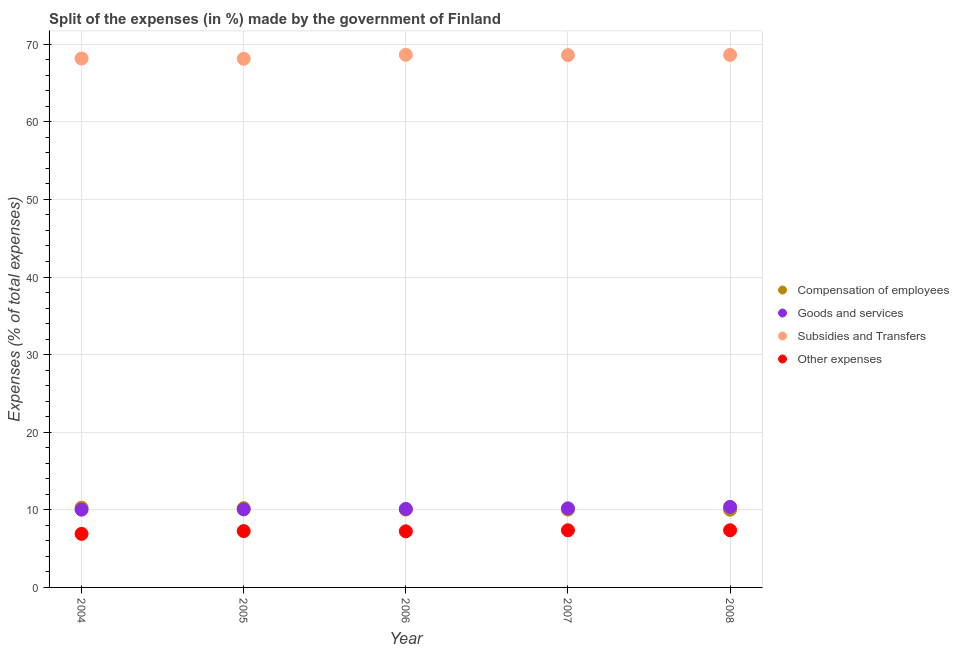How many different coloured dotlines are there?
Your answer should be compact. 4. Is the number of dotlines equal to the number of legend labels?
Offer a terse response. Yes. What is the percentage of amount spent on other expenses in 2006?
Give a very brief answer. 7.23. Across all years, what is the maximum percentage of amount spent on compensation of employees?
Ensure brevity in your answer.  10.27. Across all years, what is the minimum percentage of amount spent on other expenses?
Keep it short and to the point. 6.9. In which year was the percentage of amount spent on goods and services maximum?
Offer a very short reply. 2008. In which year was the percentage of amount spent on compensation of employees minimum?
Provide a succinct answer. 2008. What is the total percentage of amount spent on other expenses in the graph?
Your answer should be compact. 36.12. What is the difference between the percentage of amount spent on subsidies in 2004 and that in 2005?
Provide a short and direct response. 0.03. What is the difference between the percentage of amount spent on subsidies in 2008 and the percentage of amount spent on compensation of employees in 2005?
Offer a very short reply. 58.4. What is the average percentage of amount spent on other expenses per year?
Keep it short and to the point. 7.22. In the year 2007, what is the difference between the percentage of amount spent on other expenses and percentage of amount spent on compensation of employees?
Offer a terse response. -2.67. What is the ratio of the percentage of amount spent on compensation of employees in 2005 to that in 2008?
Provide a short and direct response. 1.02. Is the difference between the percentage of amount spent on compensation of employees in 2004 and 2005 greater than the difference between the percentage of amount spent on subsidies in 2004 and 2005?
Keep it short and to the point. Yes. What is the difference between the highest and the second highest percentage of amount spent on compensation of employees?
Ensure brevity in your answer.  0.05. What is the difference between the highest and the lowest percentage of amount spent on other expenses?
Offer a very short reply. 0.46. In how many years, is the percentage of amount spent on other expenses greater than the average percentage of amount spent on other expenses taken over all years?
Your response must be concise. 4. Is it the case that in every year, the sum of the percentage of amount spent on goods and services and percentage of amount spent on compensation of employees is greater than the sum of percentage of amount spent on subsidies and percentage of amount spent on other expenses?
Your answer should be compact. No. Is it the case that in every year, the sum of the percentage of amount spent on compensation of employees and percentage of amount spent on goods and services is greater than the percentage of amount spent on subsidies?
Ensure brevity in your answer.  No. Does the percentage of amount spent on compensation of employees monotonically increase over the years?
Make the answer very short. No. Is the percentage of amount spent on compensation of employees strictly greater than the percentage of amount spent on subsidies over the years?
Offer a terse response. No. Is the percentage of amount spent on goods and services strictly less than the percentage of amount spent on other expenses over the years?
Keep it short and to the point. No. How many dotlines are there?
Keep it short and to the point. 4. How many years are there in the graph?
Offer a very short reply. 5. What is the difference between two consecutive major ticks on the Y-axis?
Provide a succinct answer. 10. Does the graph contain any zero values?
Your answer should be compact. No. Does the graph contain grids?
Your answer should be very brief. Yes. How are the legend labels stacked?
Offer a very short reply. Vertical. What is the title of the graph?
Your answer should be very brief. Split of the expenses (in %) made by the government of Finland. Does "Custom duties" appear as one of the legend labels in the graph?
Your answer should be very brief. No. What is the label or title of the Y-axis?
Your response must be concise. Expenses (% of total expenses). What is the Expenses (% of total expenses) in Compensation of employees in 2004?
Give a very brief answer. 10.27. What is the Expenses (% of total expenses) of Goods and services in 2004?
Make the answer very short. 10.02. What is the Expenses (% of total expenses) of Subsidies and Transfers in 2004?
Keep it short and to the point. 68.15. What is the Expenses (% of total expenses) of Other expenses in 2004?
Offer a terse response. 6.9. What is the Expenses (% of total expenses) in Compensation of employees in 2005?
Your answer should be very brief. 10.22. What is the Expenses (% of total expenses) in Goods and services in 2005?
Give a very brief answer. 10.06. What is the Expenses (% of total expenses) of Subsidies and Transfers in 2005?
Give a very brief answer. 68.12. What is the Expenses (% of total expenses) in Other expenses in 2005?
Ensure brevity in your answer.  7.26. What is the Expenses (% of total expenses) in Compensation of employees in 2006?
Ensure brevity in your answer.  10.04. What is the Expenses (% of total expenses) in Goods and services in 2006?
Your answer should be very brief. 10.12. What is the Expenses (% of total expenses) in Subsidies and Transfers in 2006?
Offer a very short reply. 68.64. What is the Expenses (% of total expenses) in Other expenses in 2006?
Provide a succinct answer. 7.23. What is the Expenses (% of total expenses) in Compensation of employees in 2007?
Your response must be concise. 10.03. What is the Expenses (% of total expenses) in Goods and services in 2007?
Provide a short and direct response. 10.19. What is the Expenses (% of total expenses) of Subsidies and Transfers in 2007?
Make the answer very short. 68.59. What is the Expenses (% of total expenses) in Other expenses in 2007?
Offer a terse response. 7.36. What is the Expenses (% of total expenses) in Compensation of employees in 2008?
Keep it short and to the point. 10.02. What is the Expenses (% of total expenses) of Goods and services in 2008?
Provide a short and direct response. 10.38. What is the Expenses (% of total expenses) of Subsidies and Transfers in 2008?
Your answer should be compact. 68.62. What is the Expenses (% of total expenses) of Other expenses in 2008?
Provide a short and direct response. 7.36. Across all years, what is the maximum Expenses (% of total expenses) of Compensation of employees?
Give a very brief answer. 10.27. Across all years, what is the maximum Expenses (% of total expenses) in Goods and services?
Offer a very short reply. 10.38. Across all years, what is the maximum Expenses (% of total expenses) in Subsidies and Transfers?
Make the answer very short. 68.64. Across all years, what is the maximum Expenses (% of total expenses) of Other expenses?
Keep it short and to the point. 7.36. Across all years, what is the minimum Expenses (% of total expenses) in Compensation of employees?
Keep it short and to the point. 10.02. Across all years, what is the minimum Expenses (% of total expenses) of Goods and services?
Give a very brief answer. 10.02. Across all years, what is the minimum Expenses (% of total expenses) of Subsidies and Transfers?
Provide a succinct answer. 68.12. Across all years, what is the minimum Expenses (% of total expenses) of Other expenses?
Your answer should be compact. 6.9. What is the total Expenses (% of total expenses) in Compensation of employees in the graph?
Your response must be concise. 50.57. What is the total Expenses (% of total expenses) in Goods and services in the graph?
Your response must be concise. 50.77. What is the total Expenses (% of total expenses) of Subsidies and Transfers in the graph?
Your answer should be compact. 342.11. What is the total Expenses (% of total expenses) in Other expenses in the graph?
Offer a terse response. 36.12. What is the difference between the Expenses (% of total expenses) in Compensation of employees in 2004 and that in 2005?
Your response must be concise. 0.05. What is the difference between the Expenses (% of total expenses) of Goods and services in 2004 and that in 2005?
Your answer should be compact. -0.04. What is the difference between the Expenses (% of total expenses) in Subsidies and Transfers in 2004 and that in 2005?
Make the answer very short. 0.03. What is the difference between the Expenses (% of total expenses) in Other expenses in 2004 and that in 2005?
Your answer should be compact. -0.36. What is the difference between the Expenses (% of total expenses) in Compensation of employees in 2004 and that in 2006?
Your response must be concise. 0.23. What is the difference between the Expenses (% of total expenses) in Goods and services in 2004 and that in 2006?
Ensure brevity in your answer.  -0.1. What is the difference between the Expenses (% of total expenses) in Subsidies and Transfers in 2004 and that in 2006?
Your response must be concise. -0.48. What is the difference between the Expenses (% of total expenses) of Other expenses in 2004 and that in 2006?
Give a very brief answer. -0.33. What is the difference between the Expenses (% of total expenses) of Compensation of employees in 2004 and that in 2007?
Offer a very short reply. 0.24. What is the difference between the Expenses (% of total expenses) of Goods and services in 2004 and that in 2007?
Offer a terse response. -0.17. What is the difference between the Expenses (% of total expenses) of Subsidies and Transfers in 2004 and that in 2007?
Provide a short and direct response. -0.43. What is the difference between the Expenses (% of total expenses) of Other expenses in 2004 and that in 2007?
Offer a terse response. -0.46. What is the difference between the Expenses (% of total expenses) in Compensation of employees in 2004 and that in 2008?
Make the answer very short. 0.25. What is the difference between the Expenses (% of total expenses) of Goods and services in 2004 and that in 2008?
Keep it short and to the point. -0.36. What is the difference between the Expenses (% of total expenses) of Subsidies and Transfers in 2004 and that in 2008?
Provide a short and direct response. -0.47. What is the difference between the Expenses (% of total expenses) in Other expenses in 2004 and that in 2008?
Ensure brevity in your answer.  -0.46. What is the difference between the Expenses (% of total expenses) of Compensation of employees in 2005 and that in 2006?
Ensure brevity in your answer.  0.18. What is the difference between the Expenses (% of total expenses) of Goods and services in 2005 and that in 2006?
Offer a very short reply. -0.06. What is the difference between the Expenses (% of total expenses) in Subsidies and Transfers in 2005 and that in 2006?
Give a very brief answer. -0.52. What is the difference between the Expenses (% of total expenses) in Other expenses in 2005 and that in 2006?
Offer a terse response. 0.03. What is the difference between the Expenses (% of total expenses) of Compensation of employees in 2005 and that in 2007?
Give a very brief answer. 0.19. What is the difference between the Expenses (% of total expenses) in Goods and services in 2005 and that in 2007?
Your answer should be compact. -0.13. What is the difference between the Expenses (% of total expenses) of Subsidies and Transfers in 2005 and that in 2007?
Your response must be concise. -0.47. What is the difference between the Expenses (% of total expenses) of Other expenses in 2005 and that in 2007?
Offer a very short reply. -0.1. What is the difference between the Expenses (% of total expenses) of Compensation of employees in 2005 and that in 2008?
Keep it short and to the point. 0.2. What is the difference between the Expenses (% of total expenses) in Goods and services in 2005 and that in 2008?
Your answer should be very brief. -0.32. What is the difference between the Expenses (% of total expenses) in Subsidies and Transfers in 2005 and that in 2008?
Your response must be concise. -0.5. What is the difference between the Expenses (% of total expenses) in Other expenses in 2005 and that in 2008?
Your answer should be compact. -0.11. What is the difference between the Expenses (% of total expenses) in Compensation of employees in 2006 and that in 2007?
Keep it short and to the point. 0.01. What is the difference between the Expenses (% of total expenses) in Goods and services in 2006 and that in 2007?
Offer a very short reply. -0.08. What is the difference between the Expenses (% of total expenses) in Subsidies and Transfers in 2006 and that in 2007?
Your response must be concise. 0.05. What is the difference between the Expenses (% of total expenses) of Other expenses in 2006 and that in 2007?
Offer a terse response. -0.13. What is the difference between the Expenses (% of total expenses) in Compensation of employees in 2006 and that in 2008?
Your answer should be very brief. 0.02. What is the difference between the Expenses (% of total expenses) of Goods and services in 2006 and that in 2008?
Your response must be concise. -0.26. What is the difference between the Expenses (% of total expenses) of Subsidies and Transfers in 2006 and that in 2008?
Your answer should be very brief. 0.01. What is the difference between the Expenses (% of total expenses) in Other expenses in 2006 and that in 2008?
Your answer should be compact. -0.13. What is the difference between the Expenses (% of total expenses) of Compensation of employees in 2007 and that in 2008?
Make the answer very short. 0.01. What is the difference between the Expenses (% of total expenses) of Goods and services in 2007 and that in 2008?
Your answer should be compact. -0.19. What is the difference between the Expenses (% of total expenses) of Subsidies and Transfers in 2007 and that in 2008?
Your answer should be very brief. -0.03. What is the difference between the Expenses (% of total expenses) in Other expenses in 2007 and that in 2008?
Your response must be concise. -0. What is the difference between the Expenses (% of total expenses) of Compensation of employees in 2004 and the Expenses (% of total expenses) of Goods and services in 2005?
Offer a terse response. 0.21. What is the difference between the Expenses (% of total expenses) of Compensation of employees in 2004 and the Expenses (% of total expenses) of Subsidies and Transfers in 2005?
Your response must be concise. -57.85. What is the difference between the Expenses (% of total expenses) of Compensation of employees in 2004 and the Expenses (% of total expenses) of Other expenses in 2005?
Offer a terse response. 3.01. What is the difference between the Expenses (% of total expenses) in Goods and services in 2004 and the Expenses (% of total expenses) in Subsidies and Transfers in 2005?
Your response must be concise. -58.1. What is the difference between the Expenses (% of total expenses) in Goods and services in 2004 and the Expenses (% of total expenses) in Other expenses in 2005?
Your answer should be compact. 2.76. What is the difference between the Expenses (% of total expenses) of Subsidies and Transfers in 2004 and the Expenses (% of total expenses) of Other expenses in 2005?
Provide a succinct answer. 60.89. What is the difference between the Expenses (% of total expenses) of Compensation of employees in 2004 and the Expenses (% of total expenses) of Goods and services in 2006?
Provide a short and direct response. 0.15. What is the difference between the Expenses (% of total expenses) in Compensation of employees in 2004 and the Expenses (% of total expenses) in Subsidies and Transfers in 2006?
Offer a very short reply. -58.37. What is the difference between the Expenses (% of total expenses) of Compensation of employees in 2004 and the Expenses (% of total expenses) of Other expenses in 2006?
Give a very brief answer. 3.04. What is the difference between the Expenses (% of total expenses) in Goods and services in 2004 and the Expenses (% of total expenses) in Subsidies and Transfers in 2006?
Make the answer very short. -58.61. What is the difference between the Expenses (% of total expenses) in Goods and services in 2004 and the Expenses (% of total expenses) in Other expenses in 2006?
Offer a terse response. 2.79. What is the difference between the Expenses (% of total expenses) of Subsidies and Transfers in 2004 and the Expenses (% of total expenses) of Other expenses in 2006?
Give a very brief answer. 60.92. What is the difference between the Expenses (% of total expenses) of Compensation of employees in 2004 and the Expenses (% of total expenses) of Goods and services in 2007?
Ensure brevity in your answer.  0.08. What is the difference between the Expenses (% of total expenses) in Compensation of employees in 2004 and the Expenses (% of total expenses) in Subsidies and Transfers in 2007?
Ensure brevity in your answer.  -58.32. What is the difference between the Expenses (% of total expenses) in Compensation of employees in 2004 and the Expenses (% of total expenses) in Other expenses in 2007?
Ensure brevity in your answer.  2.91. What is the difference between the Expenses (% of total expenses) of Goods and services in 2004 and the Expenses (% of total expenses) of Subsidies and Transfers in 2007?
Your response must be concise. -58.56. What is the difference between the Expenses (% of total expenses) of Goods and services in 2004 and the Expenses (% of total expenses) of Other expenses in 2007?
Make the answer very short. 2.66. What is the difference between the Expenses (% of total expenses) in Subsidies and Transfers in 2004 and the Expenses (% of total expenses) in Other expenses in 2007?
Your answer should be compact. 60.79. What is the difference between the Expenses (% of total expenses) in Compensation of employees in 2004 and the Expenses (% of total expenses) in Goods and services in 2008?
Offer a very short reply. -0.11. What is the difference between the Expenses (% of total expenses) of Compensation of employees in 2004 and the Expenses (% of total expenses) of Subsidies and Transfers in 2008?
Your answer should be very brief. -58.35. What is the difference between the Expenses (% of total expenses) of Compensation of employees in 2004 and the Expenses (% of total expenses) of Other expenses in 2008?
Your answer should be very brief. 2.9. What is the difference between the Expenses (% of total expenses) in Goods and services in 2004 and the Expenses (% of total expenses) in Subsidies and Transfers in 2008?
Your response must be concise. -58.6. What is the difference between the Expenses (% of total expenses) in Goods and services in 2004 and the Expenses (% of total expenses) in Other expenses in 2008?
Your answer should be compact. 2.66. What is the difference between the Expenses (% of total expenses) of Subsidies and Transfers in 2004 and the Expenses (% of total expenses) of Other expenses in 2008?
Your answer should be very brief. 60.79. What is the difference between the Expenses (% of total expenses) in Compensation of employees in 2005 and the Expenses (% of total expenses) in Goods and services in 2006?
Give a very brief answer. 0.1. What is the difference between the Expenses (% of total expenses) of Compensation of employees in 2005 and the Expenses (% of total expenses) of Subsidies and Transfers in 2006?
Offer a terse response. -58.42. What is the difference between the Expenses (% of total expenses) in Compensation of employees in 2005 and the Expenses (% of total expenses) in Other expenses in 2006?
Your answer should be very brief. 2.99. What is the difference between the Expenses (% of total expenses) of Goods and services in 2005 and the Expenses (% of total expenses) of Subsidies and Transfers in 2006?
Provide a succinct answer. -58.58. What is the difference between the Expenses (% of total expenses) in Goods and services in 2005 and the Expenses (% of total expenses) in Other expenses in 2006?
Your answer should be very brief. 2.83. What is the difference between the Expenses (% of total expenses) in Subsidies and Transfers in 2005 and the Expenses (% of total expenses) in Other expenses in 2006?
Give a very brief answer. 60.89. What is the difference between the Expenses (% of total expenses) of Compensation of employees in 2005 and the Expenses (% of total expenses) of Goods and services in 2007?
Provide a short and direct response. 0.02. What is the difference between the Expenses (% of total expenses) in Compensation of employees in 2005 and the Expenses (% of total expenses) in Subsidies and Transfers in 2007?
Ensure brevity in your answer.  -58.37. What is the difference between the Expenses (% of total expenses) of Compensation of employees in 2005 and the Expenses (% of total expenses) of Other expenses in 2007?
Make the answer very short. 2.85. What is the difference between the Expenses (% of total expenses) of Goods and services in 2005 and the Expenses (% of total expenses) of Subsidies and Transfers in 2007?
Keep it short and to the point. -58.53. What is the difference between the Expenses (% of total expenses) in Goods and services in 2005 and the Expenses (% of total expenses) in Other expenses in 2007?
Provide a succinct answer. 2.7. What is the difference between the Expenses (% of total expenses) of Subsidies and Transfers in 2005 and the Expenses (% of total expenses) of Other expenses in 2007?
Offer a terse response. 60.76. What is the difference between the Expenses (% of total expenses) of Compensation of employees in 2005 and the Expenses (% of total expenses) of Goods and services in 2008?
Ensure brevity in your answer.  -0.16. What is the difference between the Expenses (% of total expenses) of Compensation of employees in 2005 and the Expenses (% of total expenses) of Subsidies and Transfers in 2008?
Provide a short and direct response. -58.4. What is the difference between the Expenses (% of total expenses) in Compensation of employees in 2005 and the Expenses (% of total expenses) in Other expenses in 2008?
Your answer should be very brief. 2.85. What is the difference between the Expenses (% of total expenses) of Goods and services in 2005 and the Expenses (% of total expenses) of Subsidies and Transfers in 2008?
Ensure brevity in your answer.  -58.56. What is the difference between the Expenses (% of total expenses) in Goods and services in 2005 and the Expenses (% of total expenses) in Other expenses in 2008?
Give a very brief answer. 2.69. What is the difference between the Expenses (% of total expenses) in Subsidies and Transfers in 2005 and the Expenses (% of total expenses) in Other expenses in 2008?
Offer a terse response. 60.76. What is the difference between the Expenses (% of total expenses) in Compensation of employees in 2006 and the Expenses (% of total expenses) in Goods and services in 2007?
Give a very brief answer. -0.16. What is the difference between the Expenses (% of total expenses) in Compensation of employees in 2006 and the Expenses (% of total expenses) in Subsidies and Transfers in 2007?
Offer a very short reply. -58.55. What is the difference between the Expenses (% of total expenses) of Compensation of employees in 2006 and the Expenses (% of total expenses) of Other expenses in 2007?
Ensure brevity in your answer.  2.67. What is the difference between the Expenses (% of total expenses) in Goods and services in 2006 and the Expenses (% of total expenses) in Subsidies and Transfers in 2007?
Your answer should be very brief. -58.47. What is the difference between the Expenses (% of total expenses) of Goods and services in 2006 and the Expenses (% of total expenses) of Other expenses in 2007?
Make the answer very short. 2.75. What is the difference between the Expenses (% of total expenses) of Subsidies and Transfers in 2006 and the Expenses (% of total expenses) of Other expenses in 2007?
Provide a succinct answer. 61.27. What is the difference between the Expenses (% of total expenses) of Compensation of employees in 2006 and the Expenses (% of total expenses) of Goods and services in 2008?
Make the answer very short. -0.34. What is the difference between the Expenses (% of total expenses) of Compensation of employees in 2006 and the Expenses (% of total expenses) of Subsidies and Transfers in 2008?
Make the answer very short. -58.59. What is the difference between the Expenses (% of total expenses) of Compensation of employees in 2006 and the Expenses (% of total expenses) of Other expenses in 2008?
Provide a short and direct response. 2.67. What is the difference between the Expenses (% of total expenses) of Goods and services in 2006 and the Expenses (% of total expenses) of Subsidies and Transfers in 2008?
Offer a very short reply. -58.5. What is the difference between the Expenses (% of total expenses) of Goods and services in 2006 and the Expenses (% of total expenses) of Other expenses in 2008?
Provide a short and direct response. 2.75. What is the difference between the Expenses (% of total expenses) in Subsidies and Transfers in 2006 and the Expenses (% of total expenses) in Other expenses in 2008?
Ensure brevity in your answer.  61.27. What is the difference between the Expenses (% of total expenses) of Compensation of employees in 2007 and the Expenses (% of total expenses) of Goods and services in 2008?
Your answer should be very brief. -0.35. What is the difference between the Expenses (% of total expenses) of Compensation of employees in 2007 and the Expenses (% of total expenses) of Subsidies and Transfers in 2008?
Provide a succinct answer. -58.59. What is the difference between the Expenses (% of total expenses) in Compensation of employees in 2007 and the Expenses (% of total expenses) in Other expenses in 2008?
Your response must be concise. 2.67. What is the difference between the Expenses (% of total expenses) in Goods and services in 2007 and the Expenses (% of total expenses) in Subsidies and Transfers in 2008?
Your answer should be very brief. -58.43. What is the difference between the Expenses (% of total expenses) in Goods and services in 2007 and the Expenses (% of total expenses) in Other expenses in 2008?
Your answer should be very brief. 2.83. What is the difference between the Expenses (% of total expenses) of Subsidies and Transfers in 2007 and the Expenses (% of total expenses) of Other expenses in 2008?
Your response must be concise. 61.22. What is the average Expenses (% of total expenses) in Compensation of employees per year?
Keep it short and to the point. 10.11. What is the average Expenses (% of total expenses) in Goods and services per year?
Provide a succinct answer. 10.15. What is the average Expenses (% of total expenses) in Subsidies and Transfers per year?
Offer a terse response. 68.42. What is the average Expenses (% of total expenses) in Other expenses per year?
Provide a succinct answer. 7.22. In the year 2004, what is the difference between the Expenses (% of total expenses) in Compensation of employees and Expenses (% of total expenses) in Goods and services?
Your answer should be very brief. 0.25. In the year 2004, what is the difference between the Expenses (% of total expenses) of Compensation of employees and Expenses (% of total expenses) of Subsidies and Transfers?
Provide a succinct answer. -57.88. In the year 2004, what is the difference between the Expenses (% of total expenses) of Compensation of employees and Expenses (% of total expenses) of Other expenses?
Your response must be concise. 3.37. In the year 2004, what is the difference between the Expenses (% of total expenses) of Goods and services and Expenses (% of total expenses) of Subsidies and Transfers?
Provide a short and direct response. -58.13. In the year 2004, what is the difference between the Expenses (% of total expenses) in Goods and services and Expenses (% of total expenses) in Other expenses?
Provide a succinct answer. 3.12. In the year 2004, what is the difference between the Expenses (% of total expenses) of Subsidies and Transfers and Expenses (% of total expenses) of Other expenses?
Offer a terse response. 61.25. In the year 2005, what is the difference between the Expenses (% of total expenses) in Compensation of employees and Expenses (% of total expenses) in Goods and services?
Your answer should be compact. 0.16. In the year 2005, what is the difference between the Expenses (% of total expenses) in Compensation of employees and Expenses (% of total expenses) in Subsidies and Transfers?
Your response must be concise. -57.9. In the year 2005, what is the difference between the Expenses (% of total expenses) in Compensation of employees and Expenses (% of total expenses) in Other expenses?
Ensure brevity in your answer.  2.96. In the year 2005, what is the difference between the Expenses (% of total expenses) in Goods and services and Expenses (% of total expenses) in Subsidies and Transfers?
Your answer should be compact. -58.06. In the year 2005, what is the difference between the Expenses (% of total expenses) of Goods and services and Expenses (% of total expenses) of Other expenses?
Give a very brief answer. 2.8. In the year 2005, what is the difference between the Expenses (% of total expenses) in Subsidies and Transfers and Expenses (% of total expenses) in Other expenses?
Your response must be concise. 60.86. In the year 2006, what is the difference between the Expenses (% of total expenses) of Compensation of employees and Expenses (% of total expenses) of Goods and services?
Offer a terse response. -0.08. In the year 2006, what is the difference between the Expenses (% of total expenses) in Compensation of employees and Expenses (% of total expenses) in Subsidies and Transfers?
Your response must be concise. -58.6. In the year 2006, what is the difference between the Expenses (% of total expenses) in Compensation of employees and Expenses (% of total expenses) in Other expenses?
Your answer should be compact. 2.8. In the year 2006, what is the difference between the Expenses (% of total expenses) in Goods and services and Expenses (% of total expenses) in Subsidies and Transfers?
Provide a short and direct response. -58.52. In the year 2006, what is the difference between the Expenses (% of total expenses) of Goods and services and Expenses (% of total expenses) of Other expenses?
Offer a very short reply. 2.89. In the year 2006, what is the difference between the Expenses (% of total expenses) of Subsidies and Transfers and Expenses (% of total expenses) of Other expenses?
Provide a succinct answer. 61.4. In the year 2007, what is the difference between the Expenses (% of total expenses) in Compensation of employees and Expenses (% of total expenses) in Goods and services?
Give a very brief answer. -0.16. In the year 2007, what is the difference between the Expenses (% of total expenses) of Compensation of employees and Expenses (% of total expenses) of Subsidies and Transfers?
Ensure brevity in your answer.  -58.56. In the year 2007, what is the difference between the Expenses (% of total expenses) in Compensation of employees and Expenses (% of total expenses) in Other expenses?
Give a very brief answer. 2.67. In the year 2007, what is the difference between the Expenses (% of total expenses) in Goods and services and Expenses (% of total expenses) in Subsidies and Transfers?
Give a very brief answer. -58.39. In the year 2007, what is the difference between the Expenses (% of total expenses) of Goods and services and Expenses (% of total expenses) of Other expenses?
Your answer should be very brief. 2.83. In the year 2007, what is the difference between the Expenses (% of total expenses) of Subsidies and Transfers and Expenses (% of total expenses) of Other expenses?
Make the answer very short. 61.22. In the year 2008, what is the difference between the Expenses (% of total expenses) in Compensation of employees and Expenses (% of total expenses) in Goods and services?
Provide a short and direct response. -0.36. In the year 2008, what is the difference between the Expenses (% of total expenses) of Compensation of employees and Expenses (% of total expenses) of Subsidies and Transfers?
Your answer should be compact. -58.6. In the year 2008, what is the difference between the Expenses (% of total expenses) in Compensation of employees and Expenses (% of total expenses) in Other expenses?
Provide a short and direct response. 2.65. In the year 2008, what is the difference between the Expenses (% of total expenses) in Goods and services and Expenses (% of total expenses) in Subsidies and Transfers?
Offer a terse response. -58.24. In the year 2008, what is the difference between the Expenses (% of total expenses) in Goods and services and Expenses (% of total expenses) in Other expenses?
Give a very brief answer. 3.01. In the year 2008, what is the difference between the Expenses (% of total expenses) in Subsidies and Transfers and Expenses (% of total expenses) in Other expenses?
Offer a very short reply. 61.26. What is the ratio of the Expenses (% of total expenses) of Goods and services in 2004 to that in 2005?
Your response must be concise. 1. What is the ratio of the Expenses (% of total expenses) of Subsidies and Transfers in 2004 to that in 2005?
Your response must be concise. 1. What is the ratio of the Expenses (% of total expenses) of Other expenses in 2004 to that in 2005?
Your response must be concise. 0.95. What is the ratio of the Expenses (% of total expenses) in Compensation of employees in 2004 to that in 2006?
Provide a short and direct response. 1.02. What is the ratio of the Expenses (% of total expenses) of Other expenses in 2004 to that in 2006?
Provide a short and direct response. 0.95. What is the ratio of the Expenses (% of total expenses) of Compensation of employees in 2004 to that in 2007?
Your answer should be very brief. 1.02. What is the ratio of the Expenses (% of total expenses) of Goods and services in 2004 to that in 2007?
Offer a terse response. 0.98. What is the ratio of the Expenses (% of total expenses) in Subsidies and Transfers in 2004 to that in 2007?
Provide a short and direct response. 0.99. What is the ratio of the Expenses (% of total expenses) of Other expenses in 2004 to that in 2007?
Your answer should be very brief. 0.94. What is the ratio of the Expenses (% of total expenses) in Compensation of employees in 2004 to that in 2008?
Provide a succinct answer. 1.02. What is the ratio of the Expenses (% of total expenses) of Goods and services in 2004 to that in 2008?
Offer a very short reply. 0.97. What is the ratio of the Expenses (% of total expenses) in Subsidies and Transfers in 2004 to that in 2008?
Your answer should be very brief. 0.99. What is the ratio of the Expenses (% of total expenses) in Other expenses in 2004 to that in 2008?
Provide a short and direct response. 0.94. What is the ratio of the Expenses (% of total expenses) of Compensation of employees in 2005 to that in 2006?
Provide a succinct answer. 1.02. What is the ratio of the Expenses (% of total expenses) in Subsidies and Transfers in 2005 to that in 2006?
Your response must be concise. 0.99. What is the ratio of the Expenses (% of total expenses) in Compensation of employees in 2005 to that in 2007?
Your answer should be compact. 1.02. What is the ratio of the Expenses (% of total expenses) in Goods and services in 2005 to that in 2007?
Ensure brevity in your answer.  0.99. What is the ratio of the Expenses (% of total expenses) of Subsidies and Transfers in 2005 to that in 2007?
Your response must be concise. 0.99. What is the ratio of the Expenses (% of total expenses) in Other expenses in 2005 to that in 2007?
Keep it short and to the point. 0.99. What is the ratio of the Expenses (% of total expenses) in Compensation of employees in 2005 to that in 2008?
Offer a very short reply. 1.02. What is the ratio of the Expenses (% of total expenses) in Goods and services in 2005 to that in 2008?
Ensure brevity in your answer.  0.97. What is the ratio of the Expenses (% of total expenses) of Other expenses in 2005 to that in 2008?
Your response must be concise. 0.99. What is the ratio of the Expenses (% of total expenses) in Subsidies and Transfers in 2006 to that in 2007?
Keep it short and to the point. 1. What is the ratio of the Expenses (% of total expenses) in Other expenses in 2006 to that in 2007?
Provide a short and direct response. 0.98. What is the ratio of the Expenses (% of total expenses) of Goods and services in 2006 to that in 2008?
Ensure brevity in your answer.  0.97. What is the ratio of the Expenses (% of total expenses) of Subsidies and Transfers in 2006 to that in 2008?
Ensure brevity in your answer.  1. What is the ratio of the Expenses (% of total expenses) of Compensation of employees in 2007 to that in 2008?
Keep it short and to the point. 1. What is the ratio of the Expenses (% of total expenses) of Goods and services in 2007 to that in 2008?
Your response must be concise. 0.98. What is the ratio of the Expenses (% of total expenses) in Subsidies and Transfers in 2007 to that in 2008?
Offer a very short reply. 1. What is the ratio of the Expenses (% of total expenses) in Other expenses in 2007 to that in 2008?
Provide a succinct answer. 1. What is the difference between the highest and the second highest Expenses (% of total expenses) in Compensation of employees?
Provide a short and direct response. 0.05. What is the difference between the highest and the second highest Expenses (% of total expenses) of Goods and services?
Your answer should be very brief. 0.19. What is the difference between the highest and the second highest Expenses (% of total expenses) in Subsidies and Transfers?
Your response must be concise. 0.01. What is the difference between the highest and the second highest Expenses (% of total expenses) in Other expenses?
Your answer should be compact. 0. What is the difference between the highest and the lowest Expenses (% of total expenses) in Compensation of employees?
Ensure brevity in your answer.  0.25. What is the difference between the highest and the lowest Expenses (% of total expenses) of Goods and services?
Your answer should be compact. 0.36. What is the difference between the highest and the lowest Expenses (% of total expenses) in Subsidies and Transfers?
Your response must be concise. 0.52. What is the difference between the highest and the lowest Expenses (% of total expenses) of Other expenses?
Give a very brief answer. 0.46. 